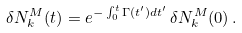<formula> <loc_0><loc_0><loc_500><loc_500>\delta N _ { k } ^ { M } ( t ) = e ^ { - \int ^ { t } _ { 0 } \Gamma ( t ^ { \prime } ) d t ^ { \prime } } \, \delta N _ { k } ^ { M } ( 0 ) \, .</formula> 